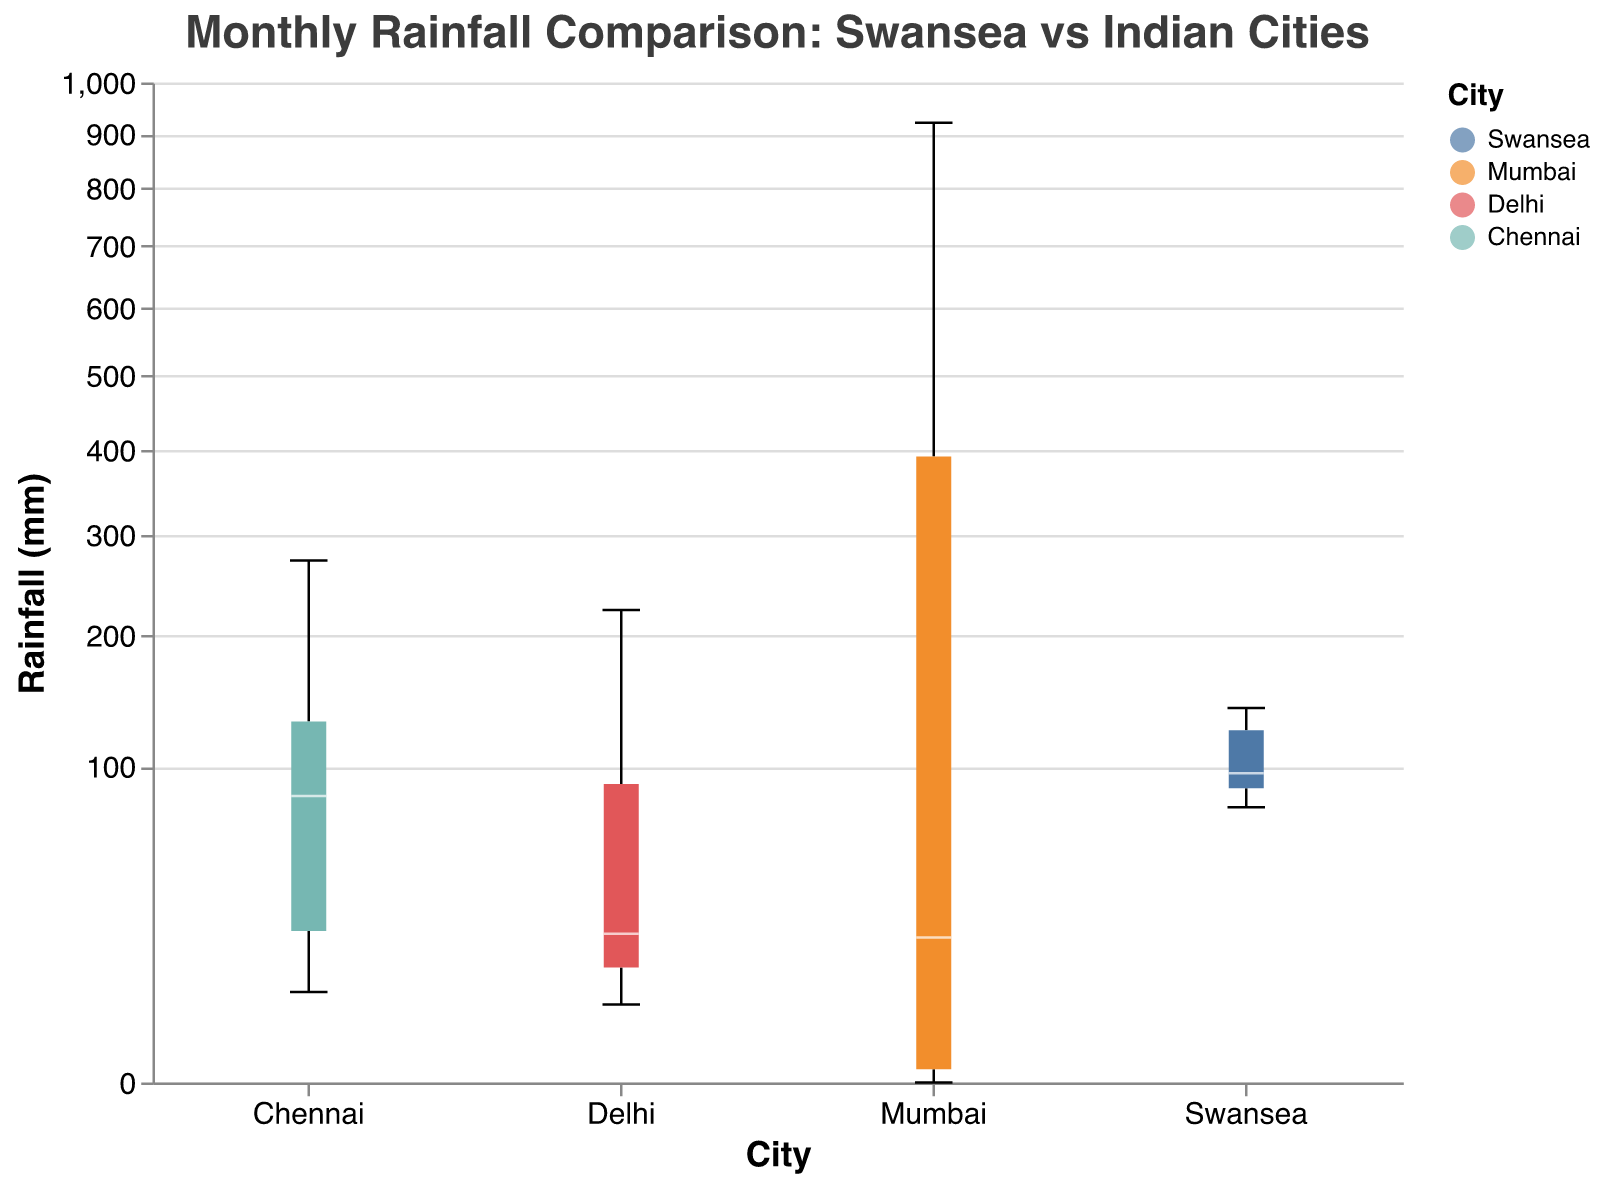What's the title of the chart? The title of the chart is typically the first element noticed. The title is displayed prominently at the top of the figure. It reads "Monthly Rainfall Comparison: Swansea vs Indian Cities."
Answer: Monthly Rainfall Comparison: Swansea vs Indian Cities Which city exhibits the highest overall rainfall during the year? To determine which city has the highest overall rainfall, we need to visually inspect the boxplot for which city has the tallest boxplot whiskers and median line. This analysis reveals that Mumbai has the highest total rainfall.
Answer: Mumbai In which month does Swansea have the highest rainfall? Look at the boxplot for Swansea and identify the month with the highest median value on the y-axis. The highest rainfall is observed in December.
Answer: December Compare the median rainfall of Mumbai and Chennai. Which city has a higher median rainfall? Identify the median rainfall for both cities by locating the white lines within their respective boxplots. Mumbai's median rainfall is higher compared to Chennai's.
Answer: Mumbai Which city has the most consistent monthly rainfall? The most consistent rainfall is seen in the city with the smallest interquartile range (the box part of the boxplot). Swansea has the most consistent monthly rainfall across the year.
Answer: Swansea How does Swansea's rainfall in July compare to Delhi's? By observing the boxplots for both Swansea and Delhi in July, one can see that Swansea's median rainfall value is lower than Delhi’s.
Answer: Lower In which month does Chennai experience the most rainfall? Inspect Chennai’s boxplots and identify the month with the highest median rainfall value. The highest rainfall occurs in November.
Answer: November What is the range of monthly rainfall for Mumbai in August? The range can be determined by observing the minimum and maximum whiskers of the boxplot for Mumbai in August. The rainfall ranges from just below 550mm to slightly above 600mm.
Answer: Approx. 550mm to 600mm Between Swansea and Chennai, which city experiences more frequent rainfall in December? By comparing the December rainfall boxplots of both cities, one can see that Swansea's median rainfall is lower than Chennai's, indicating more frequent rainfall in Chennai.
Answer: Chennai Describe the pattern of rainfall in Mumbai through the year. By sequentially analyzing Mumbai’s boxplots for each month, we see minimal rainfall from January to April, a significant increase from May peaking in July, then gradually decreasing from August to December.
Answer: Peaks in July, minimal in Jan-Apr 